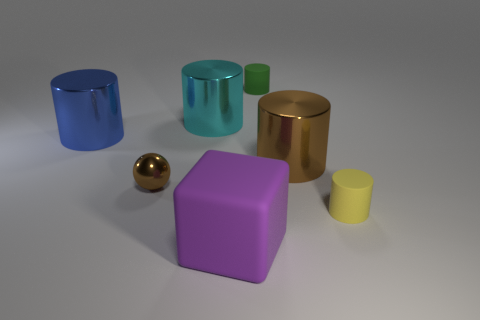Subtract all big cyan shiny cylinders. How many cylinders are left? 4 Subtract 3 cylinders. How many cylinders are left? 2 Subtract all green cylinders. How many cylinders are left? 4 Add 2 tiny brown metallic things. How many objects exist? 9 Subtract all spheres. How many objects are left? 6 Subtract all red cylinders. Subtract all gray blocks. How many cylinders are left? 5 Subtract all tiny gray blocks. Subtract all purple objects. How many objects are left? 6 Add 3 large brown things. How many large brown things are left? 4 Add 1 small green cylinders. How many small green cylinders exist? 2 Subtract 1 yellow cylinders. How many objects are left? 6 